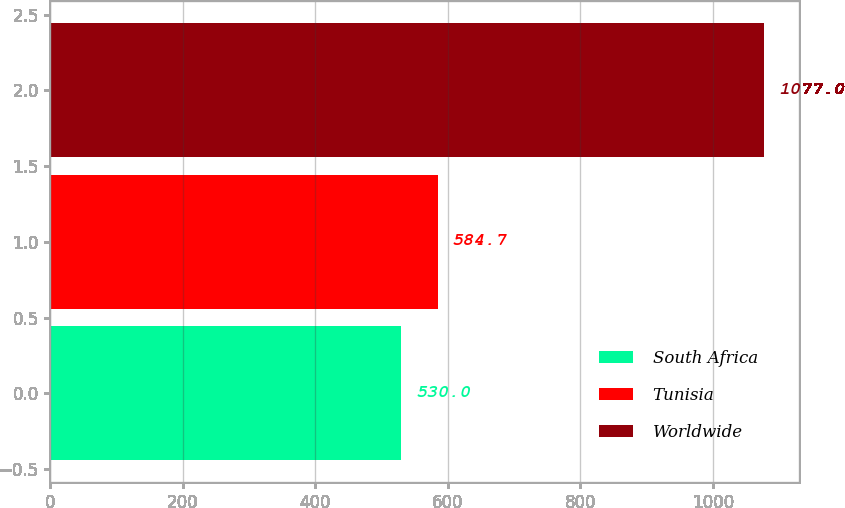<chart> <loc_0><loc_0><loc_500><loc_500><bar_chart><fcel>South Africa<fcel>Tunisia<fcel>Worldwide<nl><fcel>530<fcel>584.7<fcel>1077<nl></chart> 